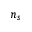Convert formula to latex. <formula><loc_0><loc_0><loc_500><loc_500>n _ { s }</formula> 